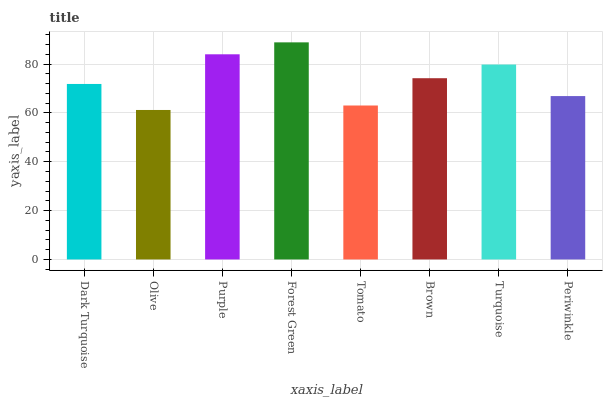Is Olive the minimum?
Answer yes or no. Yes. Is Forest Green the maximum?
Answer yes or no. Yes. Is Purple the minimum?
Answer yes or no. No. Is Purple the maximum?
Answer yes or no. No. Is Purple greater than Olive?
Answer yes or no. Yes. Is Olive less than Purple?
Answer yes or no. Yes. Is Olive greater than Purple?
Answer yes or no. No. Is Purple less than Olive?
Answer yes or no. No. Is Brown the high median?
Answer yes or no. Yes. Is Dark Turquoise the low median?
Answer yes or no. Yes. Is Periwinkle the high median?
Answer yes or no. No. Is Periwinkle the low median?
Answer yes or no. No. 